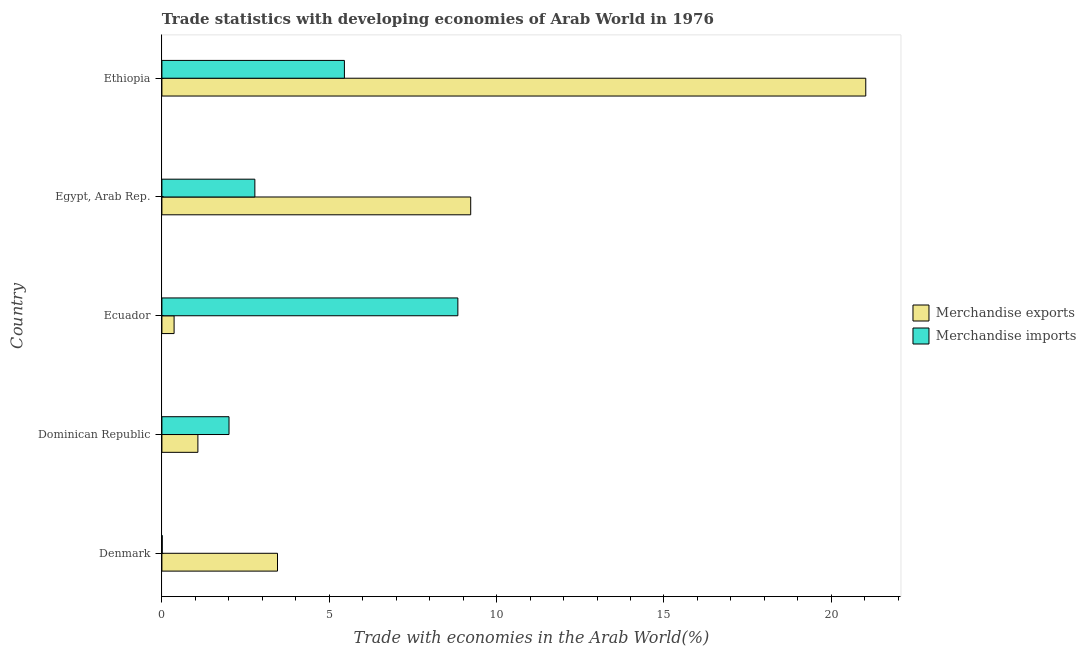How many groups of bars are there?
Provide a short and direct response. 5. Are the number of bars on each tick of the Y-axis equal?
Offer a terse response. Yes. How many bars are there on the 1st tick from the top?
Provide a short and direct response. 2. What is the merchandise imports in Ecuador?
Provide a succinct answer. 8.84. Across all countries, what is the maximum merchandise exports?
Keep it short and to the point. 21.03. Across all countries, what is the minimum merchandise exports?
Your answer should be very brief. 0.36. In which country was the merchandise exports maximum?
Provide a succinct answer. Ethiopia. In which country was the merchandise imports minimum?
Keep it short and to the point. Denmark. What is the total merchandise imports in the graph?
Offer a terse response. 19.09. What is the difference between the merchandise imports in Dominican Republic and that in Ecuador?
Your answer should be compact. -6.84. What is the difference between the merchandise exports in Dominican Republic and the merchandise imports in Egypt, Arab Rep.?
Make the answer very short. -1.7. What is the average merchandise imports per country?
Your response must be concise. 3.82. What is the difference between the merchandise exports and merchandise imports in Dominican Republic?
Ensure brevity in your answer.  -0.93. In how many countries, is the merchandise exports greater than 13 %?
Provide a short and direct response. 1. What is the ratio of the merchandise imports in Denmark to that in Ethiopia?
Provide a succinct answer. 0. Is the difference between the merchandise exports in Denmark and Egypt, Arab Rep. greater than the difference between the merchandise imports in Denmark and Egypt, Arab Rep.?
Your response must be concise. No. What is the difference between the highest and the second highest merchandise exports?
Offer a very short reply. 11.8. What is the difference between the highest and the lowest merchandise imports?
Keep it short and to the point. 8.83. Is the sum of the merchandise imports in Dominican Republic and Ecuador greater than the maximum merchandise exports across all countries?
Your answer should be very brief. No. What does the 2nd bar from the top in Denmark represents?
Provide a short and direct response. Merchandise exports. What does the 1st bar from the bottom in Dominican Republic represents?
Ensure brevity in your answer.  Merchandise exports. Are all the bars in the graph horizontal?
Provide a succinct answer. Yes. Are the values on the major ticks of X-axis written in scientific E-notation?
Provide a short and direct response. No. Does the graph contain any zero values?
Offer a very short reply. No. Does the graph contain grids?
Provide a short and direct response. No. How are the legend labels stacked?
Your answer should be very brief. Vertical. What is the title of the graph?
Ensure brevity in your answer.  Trade statistics with developing economies of Arab World in 1976. Does "National Tourists" appear as one of the legend labels in the graph?
Offer a very short reply. No. What is the label or title of the X-axis?
Keep it short and to the point. Trade with economies in the Arab World(%). What is the Trade with economies in the Arab World(%) in Merchandise exports in Denmark?
Ensure brevity in your answer.  3.45. What is the Trade with economies in the Arab World(%) in Merchandise imports in Denmark?
Your answer should be compact. 0.01. What is the Trade with economies in the Arab World(%) of Merchandise exports in Dominican Republic?
Provide a succinct answer. 1.08. What is the Trade with economies in the Arab World(%) in Merchandise imports in Dominican Republic?
Make the answer very short. 2.01. What is the Trade with economies in the Arab World(%) in Merchandise exports in Ecuador?
Offer a terse response. 0.36. What is the Trade with economies in the Arab World(%) of Merchandise imports in Ecuador?
Give a very brief answer. 8.84. What is the Trade with economies in the Arab World(%) of Merchandise exports in Egypt, Arab Rep.?
Make the answer very short. 9.23. What is the Trade with economies in the Arab World(%) in Merchandise imports in Egypt, Arab Rep.?
Ensure brevity in your answer.  2.78. What is the Trade with economies in the Arab World(%) of Merchandise exports in Ethiopia?
Offer a very short reply. 21.03. What is the Trade with economies in the Arab World(%) of Merchandise imports in Ethiopia?
Offer a terse response. 5.45. Across all countries, what is the maximum Trade with economies in the Arab World(%) of Merchandise exports?
Keep it short and to the point. 21.03. Across all countries, what is the maximum Trade with economies in the Arab World(%) in Merchandise imports?
Your response must be concise. 8.84. Across all countries, what is the minimum Trade with economies in the Arab World(%) in Merchandise exports?
Your answer should be very brief. 0.36. Across all countries, what is the minimum Trade with economies in the Arab World(%) in Merchandise imports?
Make the answer very short. 0.01. What is the total Trade with economies in the Arab World(%) of Merchandise exports in the graph?
Your response must be concise. 35.15. What is the total Trade with economies in the Arab World(%) of Merchandise imports in the graph?
Your answer should be very brief. 19.09. What is the difference between the Trade with economies in the Arab World(%) of Merchandise exports in Denmark and that in Dominican Republic?
Your answer should be very brief. 2.38. What is the difference between the Trade with economies in the Arab World(%) of Merchandise imports in Denmark and that in Dominican Republic?
Make the answer very short. -2. What is the difference between the Trade with economies in the Arab World(%) of Merchandise exports in Denmark and that in Ecuador?
Keep it short and to the point. 3.09. What is the difference between the Trade with economies in the Arab World(%) of Merchandise imports in Denmark and that in Ecuador?
Provide a short and direct response. -8.83. What is the difference between the Trade with economies in the Arab World(%) of Merchandise exports in Denmark and that in Egypt, Arab Rep.?
Provide a succinct answer. -5.77. What is the difference between the Trade with economies in the Arab World(%) in Merchandise imports in Denmark and that in Egypt, Arab Rep.?
Your answer should be compact. -2.77. What is the difference between the Trade with economies in the Arab World(%) in Merchandise exports in Denmark and that in Ethiopia?
Your response must be concise. -17.57. What is the difference between the Trade with economies in the Arab World(%) in Merchandise imports in Denmark and that in Ethiopia?
Provide a succinct answer. -5.44. What is the difference between the Trade with economies in the Arab World(%) in Merchandise exports in Dominican Republic and that in Ecuador?
Offer a very short reply. 0.71. What is the difference between the Trade with economies in the Arab World(%) in Merchandise imports in Dominican Republic and that in Ecuador?
Provide a succinct answer. -6.84. What is the difference between the Trade with economies in the Arab World(%) in Merchandise exports in Dominican Republic and that in Egypt, Arab Rep.?
Offer a very short reply. -8.15. What is the difference between the Trade with economies in the Arab World(%) of Merchandise imports in Dominican Republic and that in Egypt, Arab Rep.?
Your answer should be compact. -0.77. What is the difference between the Trade with economies in the Arab World(%) of Merchandise exports in Dominican Republic and that in Ethiopia?
Keep it short and to the point. -19.95. What is the difference between the Trade with economies in the Arab World(%) in Merchandise imports in Dominican Republic and that in Ethiopia?
Your response must be concise. -3.45. What is the difference between the Trade with economies in the Arab World(%) of Merchandise exports in Ecuador and that in Egypt, Arab Rep.?
Your answer should be very brief. -8.86. What is the difference between the Trade with economies in the Arab World(%) in Merchandise imports in Ecuador and that in Egypt, Arab Rep.?
Give a very brief answer. 6.06. What is the difference between the Trade with economies in the Arab World(%) in Merchandise exports in Ecuador and that in Ethiopia?
Provide a short and direct response. -20.66. What is the difference between the Trade with economies in the Arab World(%) in Merchandise imports in Ecuador and that in Ethiopia?
Keep it short and to the point. 3.39. What is the difference between the Trade with economies in the Arab World(%) of Merchandise exports in Egypt, Arab Rep. and that in Ethiopia?
Make the answer very short. -11.8. What is the difference between the Trade with economies in the Arab World(%) in Merchandise imports in Egypt, Arab Rep. and that in Ethiopia?
Keep it short and to the point. -2.68. What is the difference between the Trade with economies in the Arab World(%) in Merchandise exports in Denmark and the Trade with economies in the Arab World(%) in Merchandise imports in Dominican Republic?
Offer a terse response. 1.45. What is the difference between the Trade with economies in the Arab World(%) in Merchandise exports in Denmark and the Trade with economies in the Arab World(%) in Merchandise imports in Ecuador?
Your answer should be very brief. -5.39. What is the difference between the Trade with economies in the Arab World(%) in Merchandise exports in Denmark and the Trade with economies in the Arab World(%) in Merchandise imports in Egypt, Arab Rep.?
Offer a terse response. 0.68. What is the difference between the Trade with economies in the Arab World(%) of Merchandise exports in Denmark and the Trade with economies in the Arab World(%) of Merchandise imports in Ethiopia?
Your response must be concise. -2. What is the difference between the Trade with economies in the Arab World(%) in Merchandise exports in Dominican Republic and the Trade with economies in the Arab World(%) in Merchandise imports in Ecuador?
Make the answer very short. -7.77. What is the difference between the Trade with economies in the Arab World(%) of Merchandise exports in Dominican Republic and the Trade with economies in the Arab World(%) of Merchandise imports in Egypt, Arab Rep.?
Provide a short and direct response. -1.7. What is the difference between the Trade with economies in the Arab World(%) in Merchandise exports in Dominican Republic and the Trade with economies in the Arab World(%) in Merchandise imports in Ethiopia?
Keep it short and to the point. -4.38. What is the difference between the Trade with economies in the Arab World(%) of Merchandise exports in Ecuador and the Trade with economies in the Arab World(%) of Merchandise imports in Egypt, Arab Rep.?
Give a very brief answer. -2.41. What is the difference between the Trade with economies in the Arab World(%) in Merchandise exports in Ecuador and the Trade with economies in the Arab World(%) in Merchandise imports in Ethiopia?
Give a very brief answer. -5.09. What is the difference between the Trade with economies in the Arab World(%) of Merchandise exports in Egypt, Arab Rep. and the Trade with economies in the Arab World(%) of Merchandise imports in Ethiopia?
Give a very brief answer. 3.77. What is the average Trade with economies in the Arab World(%) of Merchandise exports per country?
Your answer should be compact. 7.03. What is the average Trade with economies in the Arab World(%) in Merchandise imports per country?
Your answer should be compact. 3.82. What is the difference between the Trade with economies in the Arab World(%) of Merchandise exports and Trade with economies in the Arab World(%) of Merchandise imports in Denmark?
Keep it short and to the point. 3.44. What is the difference between the Trade with economies in the Arab World(%) of Merchandise exports and Trade with economies in the Arab World(%) of Merchandise imports in Dominican Republic?
Provide a succinct answer. -0.93. What is the difference between the Trade with economies in the Arab World(%) of Merchandise exports and Trade with economies in the Arab World(%) of Merchandise imports in Ecuador?
Keep it short and to the point. -8.48. What is the difference between the Trade with economies in the Arab World(%) of Merchandise exports and Trade with economies in the Arab World(%) of Merchandise imports in Egypt, Arab Rep.?
Make the answer very short. 6.45. What is the difference between the Trade with economies in the Arab World(%) of Merchandise exports and Trade with economies in the Arab World(%) of Merchandise imports in Ethiopia?
Give a very brief answer. 15.58. What is the ratio of the Trade with economies in the Arab World(%) in Merchandise exports in Denmark to that in Dominican Republic?
Offer a very short reply. 3.21. What is the ratio of the Trade with economies in the Arab World(%) in Merchandise imports in Denmark to that in Dominican Republic?
Provide a succinct answer. 0. What is the ratio of the Trade with economies in the Arab World(%) in Merchandise exports in Denmark to that in Ecuador?
Offer a terse response. 9.48. What is the ratio of the Trade with economies in the Arab World(%) of Merchandise imports in Denmark to that in Ecuador?
Provide a short and direct response. 0. What is the ratio of the Trade with economies in the Arab World(%) of Merchandise exports in Denmark to that in Egypt, Arab Rep.?
Provide a succinct answer. 0.37. What is the ratio of the Trade with economies in the Arab World(%) of Merchandise imports in Denmark to that in Egypt, Arab Rep.?
Your response must be concise. 0. What is the ratio of the Trade with economies in the Arab World(%) of Merchandise exports in Denmark to that in Ethiopia?
Offer a very short reply. 0.16. What is the ratio of the Trade with economies in the Arab World(%) of Merchandise imports in Denmark to that in Ethiopia?
Provide a succinct answer. 0. What is the ratio of the Trade with economies in the Arab World(%) in Merchandise exports in Dominican Republic to that in Ecuador?
Make the answer very short. 2.95. What is the ratio of the Trade with economies in the Arab World(%) in Merchandise imports in Dominican Republic to that in Ecuador?
Ensure brevity in your answer.  0.23. What is the ratio of the Trade with economies in the Arab World(%) of Merchandise exports in Dominican Republic to that in Egypt, Arab Rep.?
Offer a very short reply. 0.12. What is the ratio of the Trade with economies in the Arab World(%) in Merchandise imports in Dominican Republic to that in Egypt, Arab Rep.?
Your response must be concise. 0.72. What is the ratio of the Trade with economies in the Arab World(%) of Merchandise exports in Dominican Republic to that in Ethiopia?
Provide a short and direct response. 0.05. What is the ratio of the Trade with economies in the Arab World(%) in Merchandise imports in Dominican Republic to that in Ethiopia?
Make the answer very short. 0.37. What is the ratio of the Trade with economies in the Arab World(%) in Merchandise exports in Ecuador to that in Egypt, Arab Rep.?
Give a very brief answer. 0.04. What is the ratio of the Trade with economies in the Arab World(%) of Merchandise imports in Ecuador to that in Egypt, Arab Rep.?
Provide a succinct answer. 3.18. What is the ratio of the Trade with economies in the Arab World(%) in Merchandise exports in Ecuador to that in Ethiopia?
Give a very brief answer. 0.02. What is the ratio of the Trade with economies in the Arab World(%) of Merchandise imports in Ecuador to that in Ethiopia?
Ensure brevity in your answer.  1.62. What is the ratio of the Trade with economies in the Arab World(%) in Merchandise exports in Egypt, Arab Rep. to that in Ethiopia?
Keep it short and to the point. 0.44. What is the ratio of the Trade with economies in the Arab World(%) of Merchandise imports in Egypt, Arab Rep. to that in Ethiopia?
Offer a terse response. 0.51. What is the difference between the highest and the second highest Trade with economies in the Arab World(%) of Merchandise exports?
Offer a very short reply. 11.8. What is the difference between the highest and the second highest Trade with economies in the Arab World(%) of Merchandise imports?
Offer a very short reply. 3.39. What is the difference between the highest and the lowest Trade with economies in the Arab World(%) of Merchandise exports?
Your answer should be very brief. 20.66. What is the difference between the highest and the lowest Trade with economies in the Arab World(%) of Merchandise imports?
Provide a succinct answer. 8.83. 